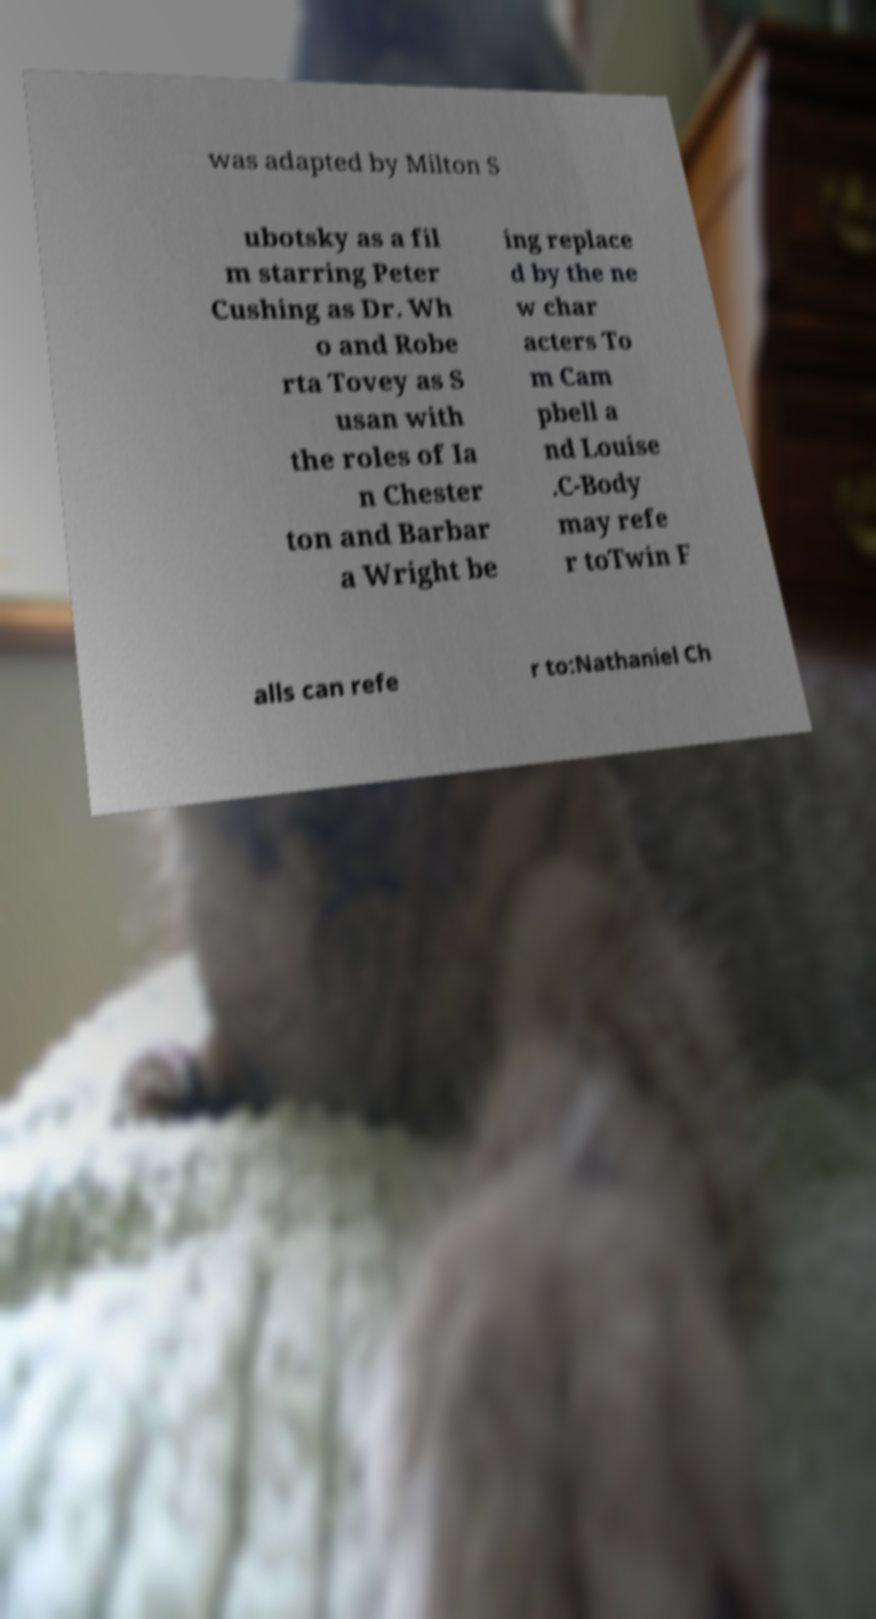Please read and relay the text visible in this image. What does it say? was adapted by Milton S ubotsky as a fil m starring Peter Cushing as Dr. Wh o and Robe rta Tovey as S usan with the roles of Ia n Chester ton and Barbar a Wright be ing replace d by the ne w char acters To m Cam pbell a nd Louise .C-Body may refe r toTwin F alls can refe r to:Nathaniel Ch 